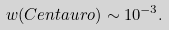<formula> <loc_0><loc_0><loc_500><loc_500>w ( C e n t a u r o ) \sim 1 0 ^ { - 3 } .</formula> 